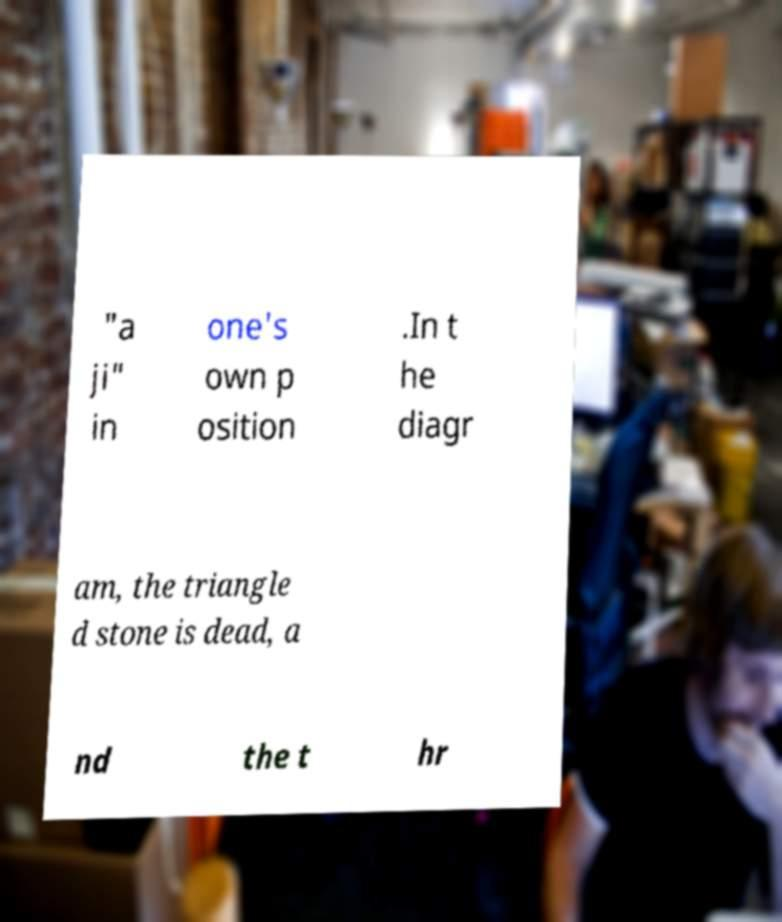Could you assist in decoding the text presented in this image and type it out clearly? "a ji" in one's own p osition .In t he diagr am, the triangle d stone is dead, a nd the t hr 